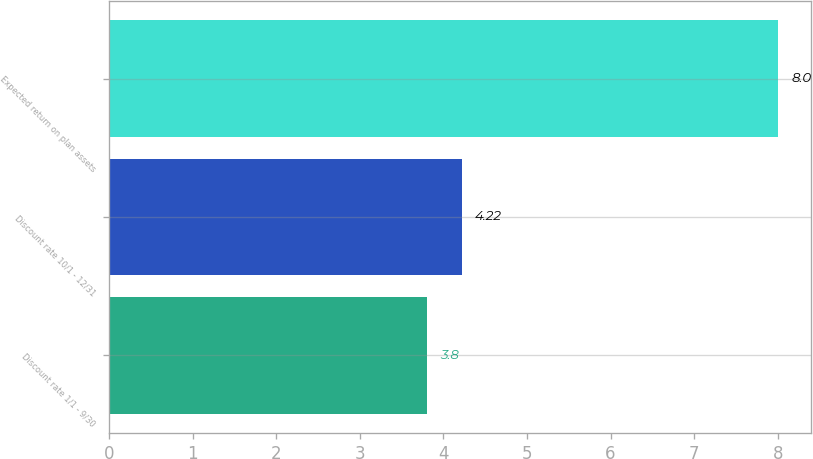<chart> <loc_0><loc_0><loc_500><loc_500><bar_chart><fcel>Discount rate 1/1 - 9/30<fcel>Discount rate 10/1 - 12/31<fcel>Expected return on plan assets<nl><fcel>3.8<fcel>4.22<fcel>8<nl></chart> 